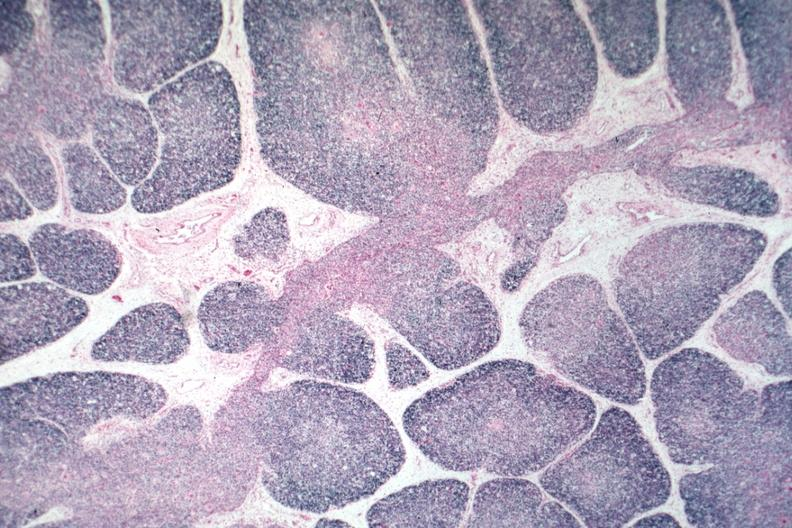s hematologic present?
Answer the question using a single word or phrase. Yes 